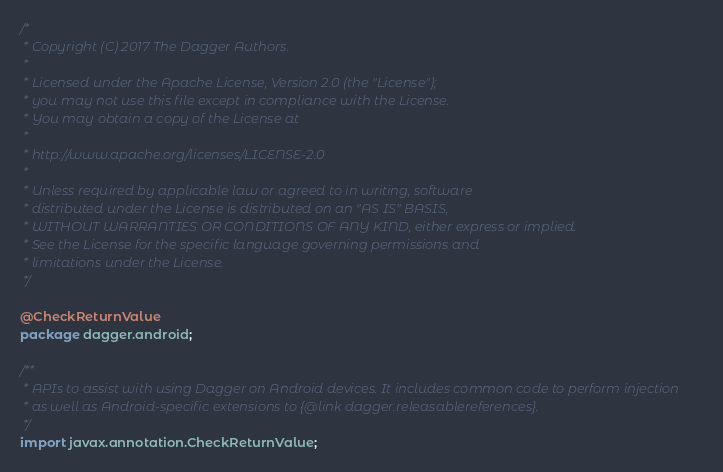<code> <loc_0><loc_0><loc_500><loc_500><_Java_>/*
 * Copyright (C) 2017 The Dagger Authors.
 *
 * Licensed under the Apache License, Version 2.0 (the "License");
 * you may not use this file except in compliance with the License.
 * You may obtain a copy of the License at
 *
 * http://www.apache.org/licenses/LICENSE-2.0
 *
 * Unless required by applicable law or agreed to in writing, software
 * distributed under the License is distributed on an "AS IS" BASIS,
 * WITHOUT WARRANTIES OR CONDITIONS OF ANY KIND, either express or implied.
 * See the License for the specific language governing permissions and
 * limitations under the License.
 */

@CheckReturnValue
package dagger.android;

/**
 * APIs to assist with using Dagger on Android devices. It includes common code to perform injection
 * as well as Android-specific extensions to {@link dagger.releasablereferences}.
 */
import javax.annotation.CheckReturnValue;
</code> 